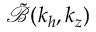Convert formula to latex. <formula><loc_0><loc_0><loc_500><loc_500>\tilde { \mathcal { B } } ( k _ { h } , k _ { z } )</formula> 